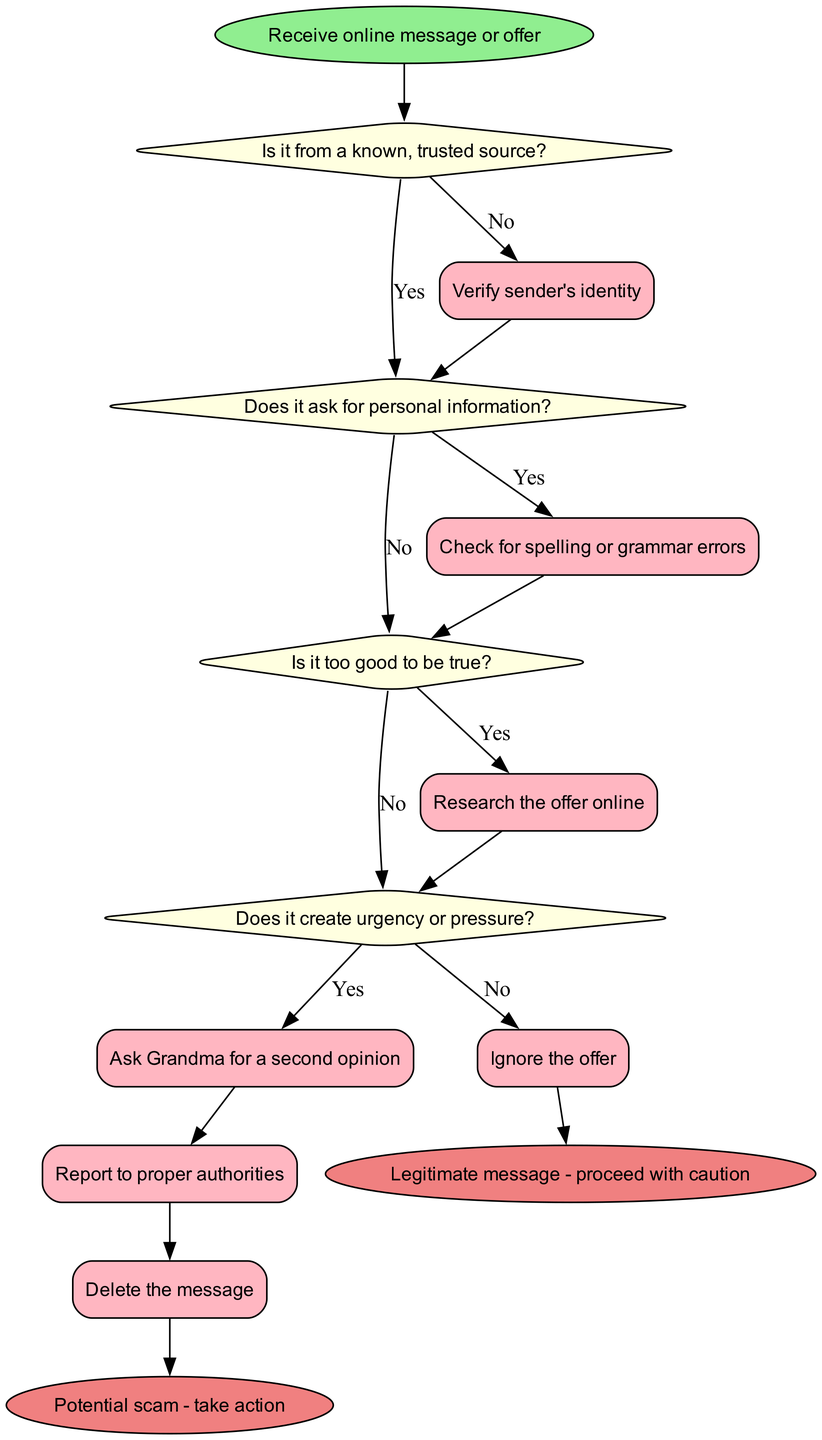What is the start node of the flowchart? The start node is labeled "Receive online message or offer." This is the first action indicated in the flowchart, setting the context for the flow of decisions and actions that follow.
Answer: Receive online message or offer How many decision nodes are present in the flowchart? There are four decision nodes listed, each representing a specific question or condition regarding the message received. These nodes are essential for determining the flow of actions based on the answers.
Answer: 4 What action is taken if the message is from a known, trusted source? If the answer to the decision node "Is it from a known, trusted source?" is "Yes," the flow proceeds to the action node where it checks for spelling or grammar errors. This indicates a step to verify the legitimacy of the message.
Answer: Check for spelling or grammar errors What happens if the offer is not too good to be true? If the decision node "Is it too good to be true?" is answered with "No," the flow leads to the action node "Ask Grandma for a second opinion." This suggests seeking additional advice to ensure informed decision-making.
Answer: Ask Grandma for a second opinion What do you do if the message creates urgency or pressure? When encountering the decision node "Does it create urgency or pressure?" with an answer of "Yes," the next action is to report the message to proper authorities, indicating a response to potential scams.
Answer: Report to proper authorities What is the final outcome if the message is identified as legitimate? If the flow concludes with the determination of a legitimate message, the end node specifies to "Legitimate message - proceed with caution" as the respective advice, showing that caution is still advised.
Answer: Legitimate message - proceed with caution What action is connected to the decision "Does it ask for personal information?" if answered "Yes"? The action node linked to the decision "Does it ask for personal information?" when answered "Yes" is to verify the sender's identity. This step underscores the importance of ensuring the legitimacy of the request.
Answer: Verify sender's identity How does the flowchart suggest handling a potential scam? When a message is considered a potential scam, the flowchart directs to reporting the message to the proper authorities. This indicates a proactive measure taken in response to suspicious activity.
Answer: Report to proper authorities 